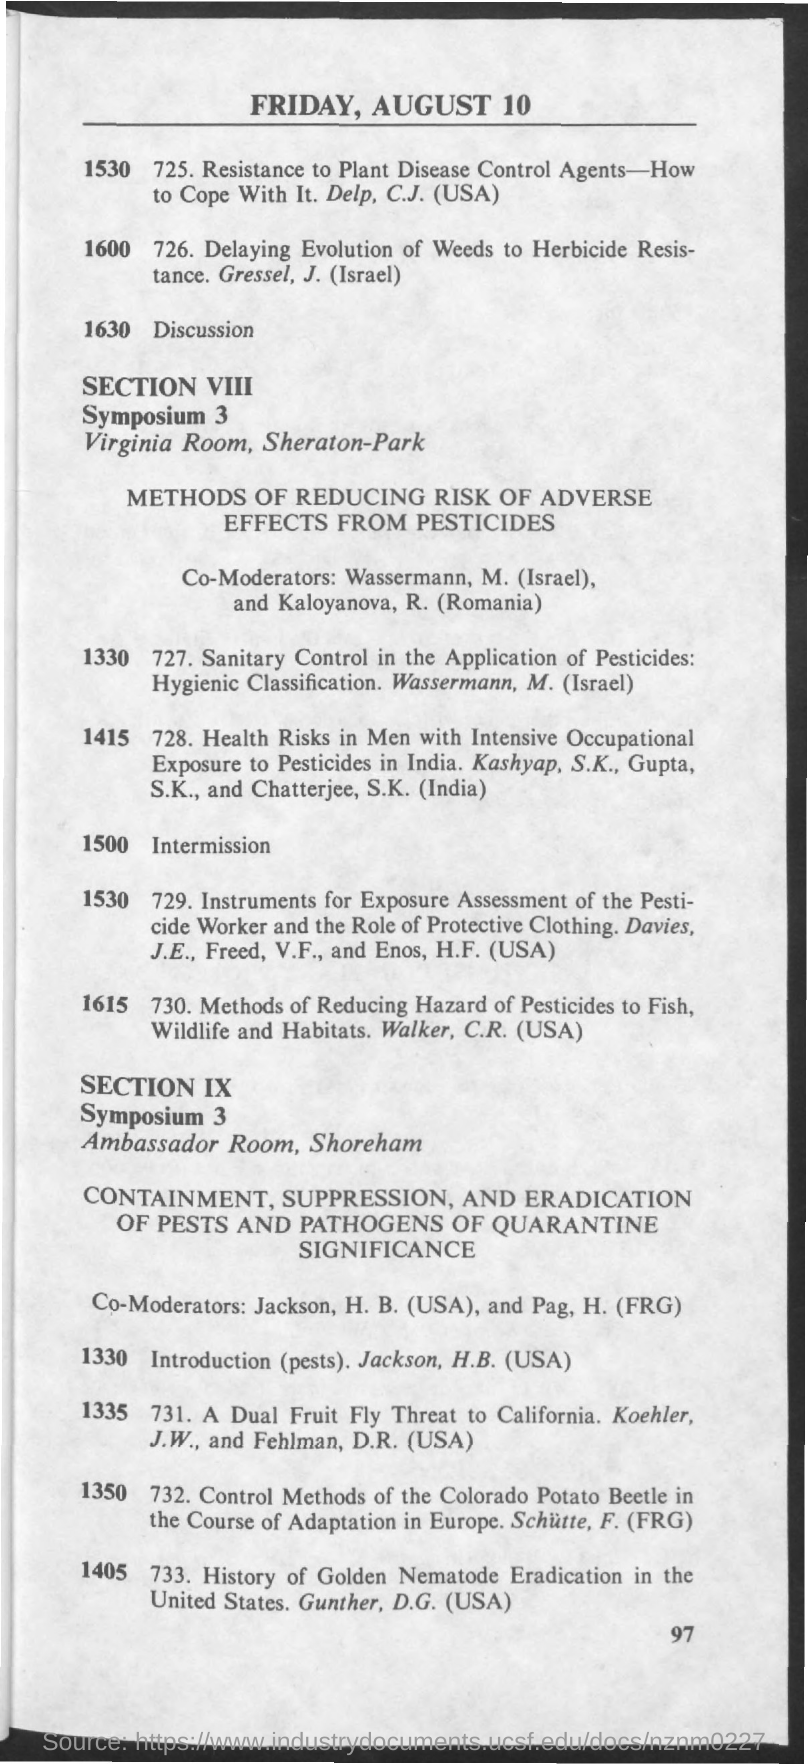Mention a couple of crucial points in this snapshot. The Page Number is 97 